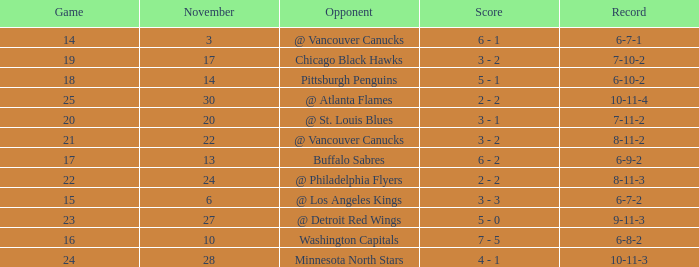What is the game when on november 27? 23.0. 